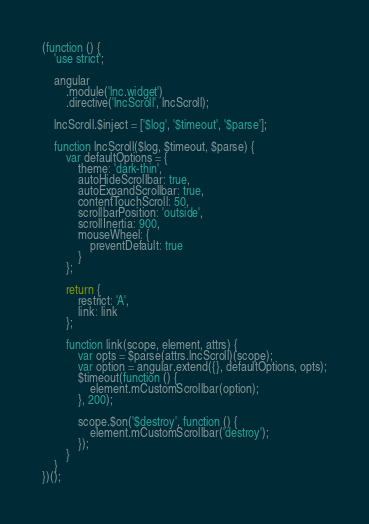Convert code to text. <code><loc_0><loc_0><loc_500><loc_500><_JavaScript_>(function () {
    'use strict';

    angular
        .module('lnc.widget')
        .directive('lncScroll', lncScroll);

    lncScroll.$inject = ['$log', '$timeout', '$parse'];

    function lncScroll($log, $timeout, $parse) {
        var defaultOptions = {
            theme: 'dark-thin',
            autoHideScrollbar: true,
            autoExpandScrollbar: true,
            contentTouchScroll: 50,
            scrollbarPosition: 'outside',
            scrollInertia: 900,
            mouseWheel: {
                preventDefault: true
            }
        };

        return {
            restrict: 'A',
            link: link
        };

        function link(scope, element, attrs) {
            var opts = $parse(attrs.lncScroll)(scope);
            var option = angular.extend({}, defaultOptions, opts);
            $timeout(function () {
                element.mCustomScrollbar(option);
            }, 200);

            scope.$on('$destroy', function () {
                element.mCustomScrollbar('destroy');
            });
        }
    }
})();

</code> 